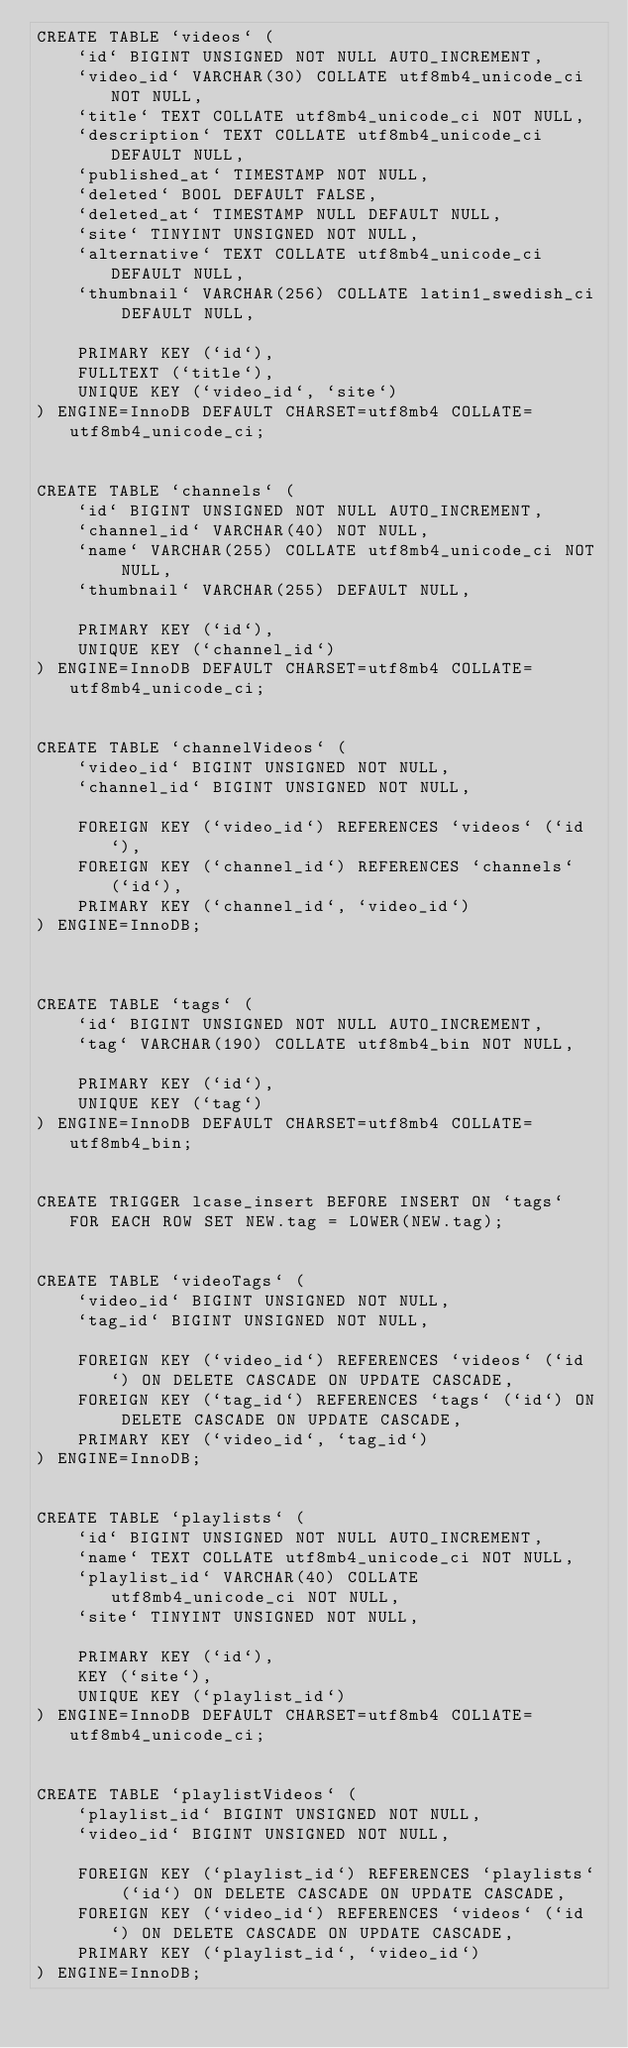Convert code to text. <code><loc_0><loc_0><loc_500><loc_500><_SQL_>CREATE TABLE `videos` (
    `id` BIGINT UNSIGNED NOT NULL AUTO_INCREMENT,
    `video_id` VARCHAR(30) COLLATE utf8mb4_unicode_ci NOT NULL,
    `title` TEXT COLLATE utf8mb4_unicode_ci NOT NULL,
    `description` TEXT COLLATE utf8mb4_unicode_ci DEFAULT NULL,
    `published_at` TIMESTAMP NOT NULL,
    `deleted` BOOL DEFAULT FALSE,
    `deleted_at` TIMESTAMP NULL DEFAULT NULL,
    `site` TINYINT UNSIGNED NOT NULL,
    `alternative` TEXT COLLATE utf8mb4_unicode_ci DEFAULT NULL,
    `thumbnail` VARCHAR(256) COLLATE latin1_swedish_ci DEFAULT NULL,

    PRIMARY KEY (`id`),
    FULLTEXT (`title`),
    UNIQUE KEY (`video_id`, `site`)
) ENGINE=InnoDB DEFAULT CHARSET=utf8mb4 COLLATE=utf8mb4_unicode_ci;


CREATE TABLE `channels` (
    `id` BIGINT UNSIGNED NOT NULL AUTO_INCREMENT,
    `channel_id` VARCHAR(40) NOT NULL,
    `name` VARCHAR(255) COLLATE utf8mb4_unicode_ci NOT NULL,
    `thumbnail` VARCHAR(255) DEFAULT NULL,

    PRIMARY KEY (`id`),
    UNIQUE KEY (`channel_id`)
) ENGINE=InnoDB DEFAULT CHARSET=utf8mb4 COLLATE=utf8mb4_unicode_ci;


CREATE TABLE `channelVideos` (
    `video_id` BIGINT UNSIGNED NOT NULL,
    `channel_id` BIGINT UNSIGNED NOT NULL,

    FOREIGN KEY (`video_id`) REFERENCES `videos` (`id`),
    FOREIGN KEY (`channel_id`) REFERENCES `channels` (`id`),
    PRIMARY KEY (`channel_id`, `video_id`)
) ENGINE=InnoDB;



CREATE TABLE `tags` (
    `id` BIGINT UNSIGNED NOT NULL AUTO_INCREMENT,
    `tag` VARCHAR(190) COLLATE utf8mb4_bin NOT NULL,

    PRIMARY KEY (`id`),
    UNIQUE KEY (`tag`)
) ENGINE=InnoDB DEFAULT CHARSET=utf8mb4 COLLATE=utf8mb4_bin;


CREATE TRIGGER lcase_insert BEFORE INSERT ON `tags` FOR EACH ROW SET NEW.tag = LOWER(NEW.tag);


CREATE TABLE `videoTags` (
    `video_id` BIGINT UNSIGNED NOT NULL,
    `tag_id` BIGINT UNSIGNED NOT NULL,

    FOREIGN KEY (`video_id`) REFERENCES `videos` (`id`) ON DELETE CASCADE ON UPDATE CASCADE,
    FOREIGN KEY (`tag_id`) REFERENCES `tags` (`id`) ON DELETE CASCADE ON UPDATE CASCADE,
    PRIMARY KEY (`video_id`, `tag_id`)
) ENGINE=InnoDB;


CREATE TABLE `playlists` (
    `id` BIGINT UNSIGNED NOT NULL AUTO_INCREMENT,
    `name` TEXT COLLATE utf8mb4_unicode_ci NOT NULL,
    `playlist_id` VARCHAR(40) COLLATE utf8mb4_unicode_ci NOT NULL,
    `site` TINYINT UNSIGNED NOT NULL,

    PRIMARY KEY (`id`),
    KEY (`site`),
    UNIQUE KEY (`playlist_id`)
) ENGINE=InnoDB DEFAULT CHARSET=utf8mb4 COLlATE=utf8mb4_unicode_ci;


CREATE TABLE `playlistVideos` (
    `playlist_id` BIGINT UNSIGNED NOT NULL,
    `video_id` BIGINT UNSIGNED NOT NULL,

    FOREIGN KEY (`playlist_id`) REFERENCES `playlists` (`id`) ON DELETE CASCADE ON UPDATE CASCADE,
    FOREIGN KEY (`video_id`) REFERENCES `videos` (`id`) ON DELETE CASCADE ON UPDATE CASCADE,
    PRIMARY KEY (`playlist_id`, `video_id`)
) ENGINE=InnoDB;
</code> 